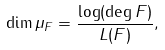Convert formula to latex. <formula><loc_0><loc_0><loc_500><loc_500>\dim \mu _ { F } = \frac { \log ( \deg F ) } { L ( F ) } ,</formula> 